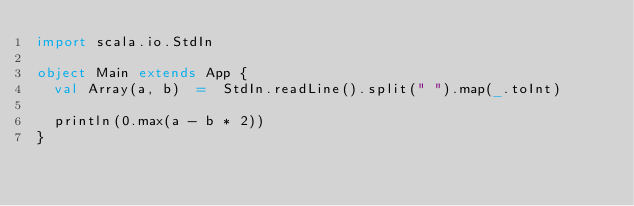Convert code to text. <code><loc_0><loc_0><loc_500><loc_500><_Scala_>import scala.io.StdIn

object Main extends App {
  val Array(a, b)  =  StdIn.readLine().split(" ").map(_.toInt)

  println(0.max(a - b * 2))
}
  

</code> 